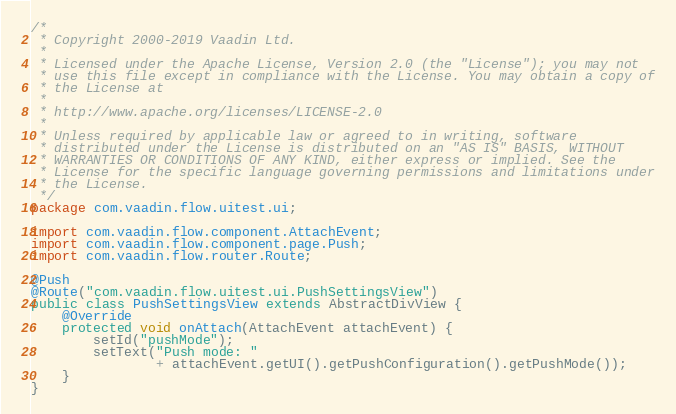Convert code to text. <code><loc_0><loc_0><loc_500><loc_500><_Java_>/*
 * Copyright 2000-2019 Vaadin Ltd.
 *
 * Licensed under the Apache License, Version 2.0 (the "License"); you may not
 * use this file except in compliance with the License. You may obtain a copy of
 * the License at
 *
 * http://www.apache.org/licenses/LICENSE-2.0
 *
 * Unless required by applicable law or agreed to in writing, software
 * distributed under the License is distributed on an "AS IS" BASIS, WITHOUT
 * WARRANTIES OR CONDITIONS OF ANY KIND, either express or implied. See the
 * License for the specific language governing permissions and limitations under
 * the License.
 */
package com.vaadin.flow.uitest.ui;

import com.vaadin.flow.component.AttachEvent;
import com.vaadin.flow.component.page.Push;
import com.vaadin.flow.router.Route;

@Push
@Route("com.vaadin.flow.uitest.ui.PushSettingsView")
public class PushSettingsView extends AbstractDivView {
    @Override
    protected void onAttach(AttachEvent attachEvent) {
        setId("pushMode");
        setText("Push mode: "
                + attachEvent.getUI().getPushConfiguration().getPushMode());
    }
}
</code> 